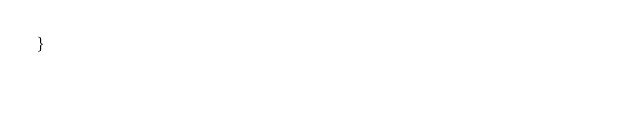<code> <loc_0><loc_0><loc_500><loc_500><_TypeScript_>}
</code> 